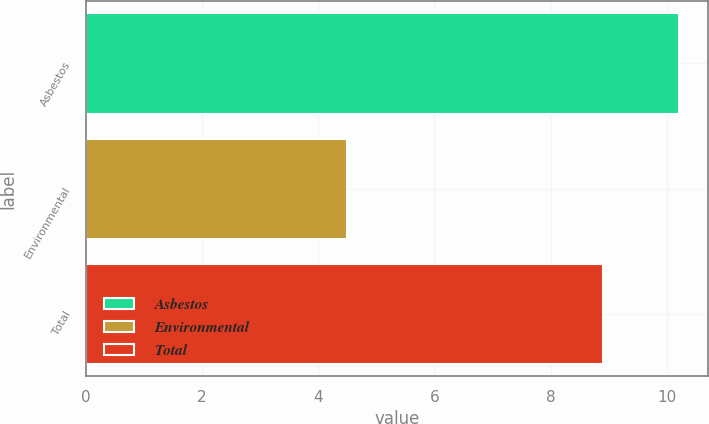<chart> <loc_0><loc_0><loc_500><loc_500><bar_chart><fcel>Asbestos<fcel>Environmental<fcel>Total<nl><fcel>10.2<fcel>4.5<fcel>8.9<nl></chart> 